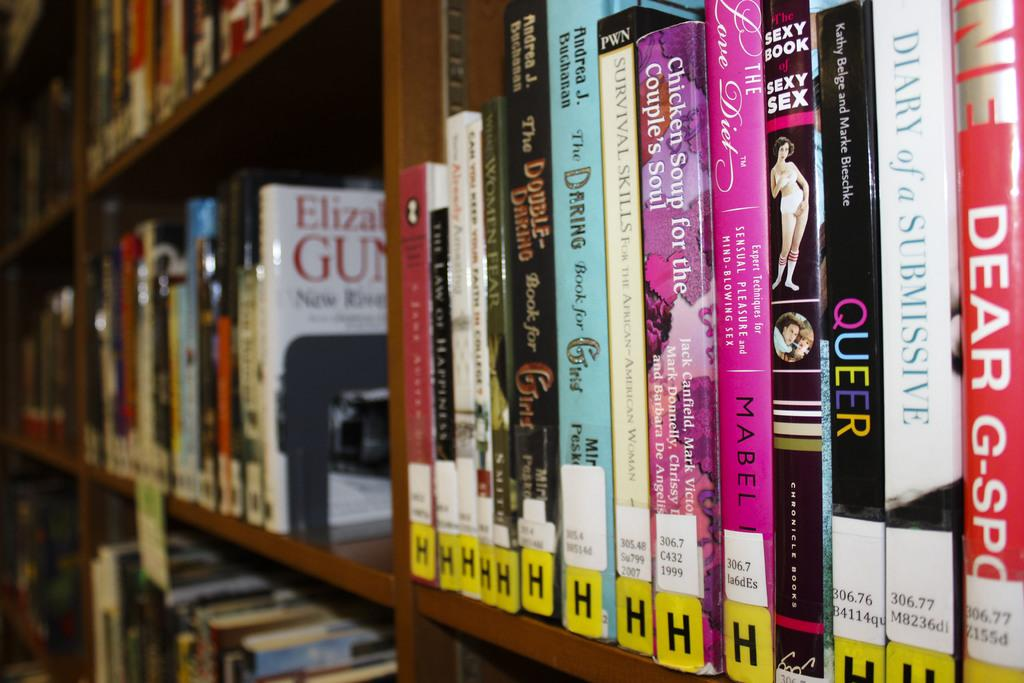<image>
Give a short and clear explanation of the subsequent image. a shelf of books in a library on row H 